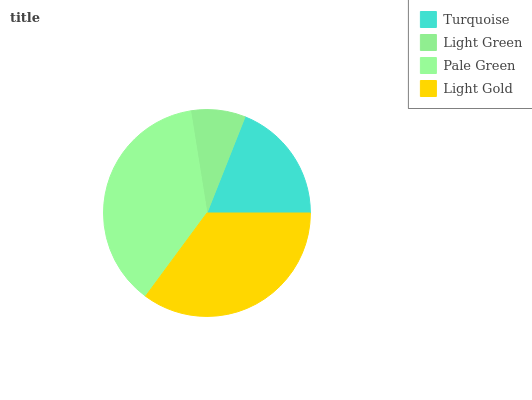Is Light Green the minimum?
Answer yes or no. Yes. Is Pale Green the maximum?
Answer yes or no. Yes. Is Pale Green the minimum?
Answer yes or no. No. Is Light Green the maximum?
Answer yes or no. No. Is Pale Green greater than Light Green?
Answer yes or no. Yes. Is Light Green less than Pale Green?
Answer yes or no. Yes. Is Light Green greater than Pale Green?
Answer yes or no. No. Is Pale Green less than Light Green?
Answer yes or no. No. Is Light Gold the high median?
Answer yes or no. Yes. Is Turquoise the low median?
Answer yes or no. Yes. Is Turquoise the high median?
Answer yes or no. No. Is Light Gold the low median?
Answer yes or no. No. 